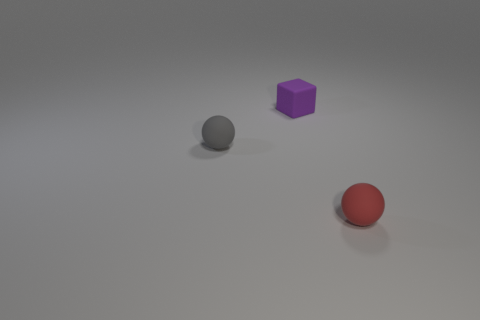How many other objects are there of the same color as the small matte cube?
Your answer should be compact. 0. Do the tiny purple object that is to the right of the small gray ball and the small thing that is in front of the tiny gray rubber ball have the same material?
Offer a terse response. Yes. Are there an equal number of small red matte spheres that are left of the block and balls that are left of the small gray matte sphere?
Provide a succinct answer. Yes. There is a small thing that is on the right side of the block; what is its material?
Your response must be concise. Rubber. Is there any other thing that is the same size as the cube?
Offer a terse response. Yes. Are there fewer red rubber spheres than small gray metal cubes?
Ensure brevity in your answer.  No. What is the shape of the object that is both on the right side of the gray thing and in front of the small rubber block?
Your answer should be compact. Sphere. How many tiny cyan things are there?
Your answer should be compact. 0. There is a thing in front of the tiny matte sphere that is behind the rubber sphere that is right of the gray matte ball; what is it made of?
Your answer should be very brief. Rubber. How many tiny purple cubes are in front of the sphere that is right of the tiny purple object?
Keep it short and to the point. 0. 